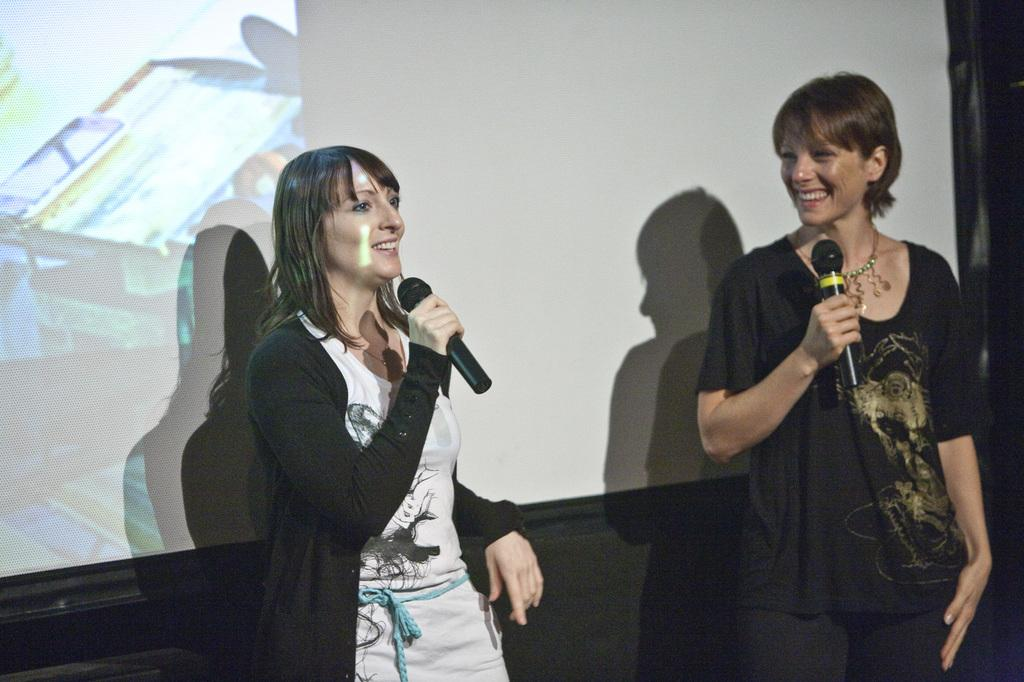How many people are in the image? There are two women in the image. What are the women holding in the image? Both women are holding microphones. What is the facial expression of the women in the image? The women are smiling. What can be seen in the background of the image? There is a projector screen in the background of the image. How many screws are visible on the women's clothing in the image? There are no screws visible on the women's clothing in the image. What type of chairs are present in the image? There is no mention of chairs in the provided facts, so we cannot determine if any are present in the image. 